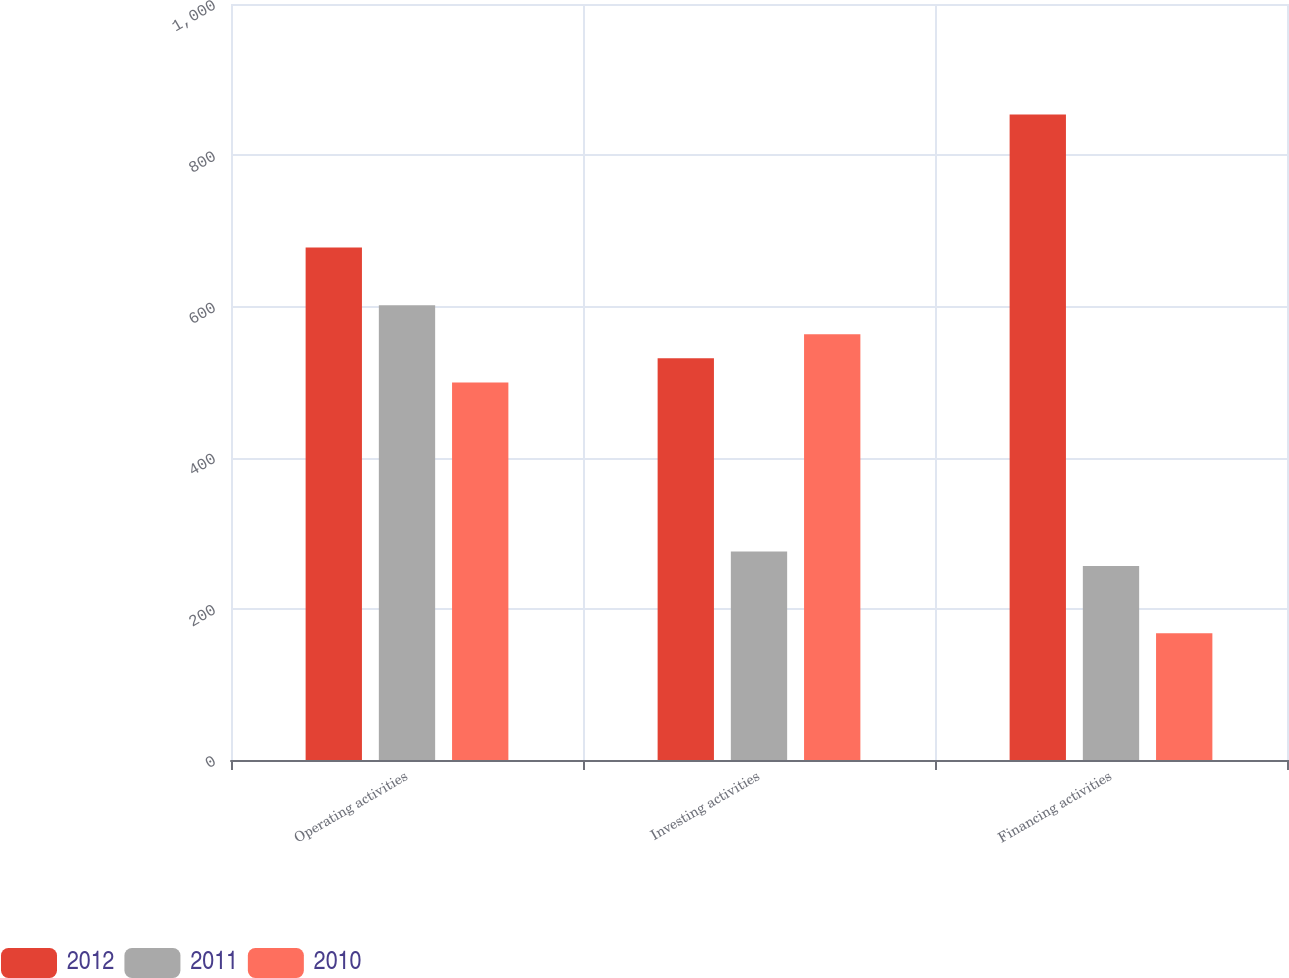Convert chart. <chart><loc_0><loc_0><loc_500><loc_500><stacked_bar_chart><ecel><fcel>Operating activities<fcel>Investing activities<fcel>Financing activities<nl><fcel>2012<fcel>677.9<fcel>531.4<fcel>853.9<nl><fcel>2011<fcel>601.6<fcel>275.7<fcel>256.7<nl><fcel>2010<fcel>499.5<fcel>563.3<fcel>167.6<nl></chart> 